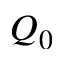<formula> <loc_0><loc_0><loc_500><loc_500>Q _ { 0 }</formula> 